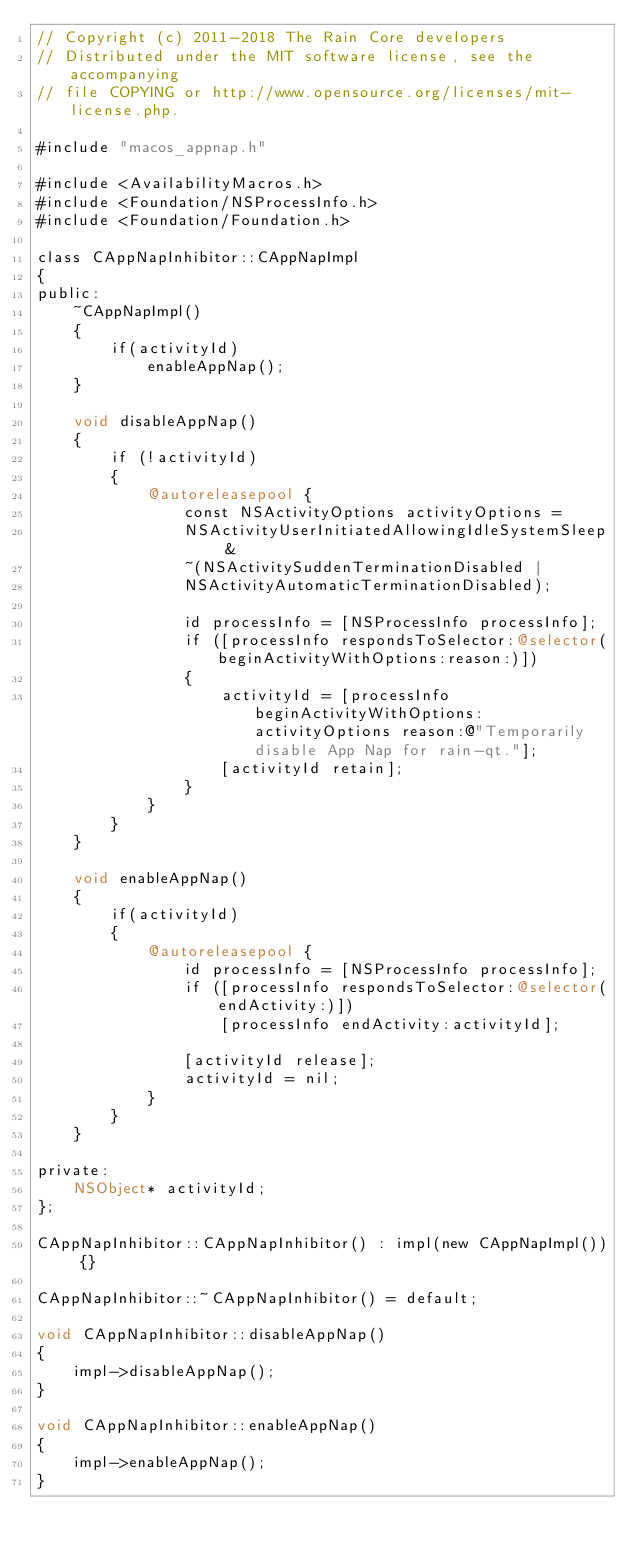Convert code to text. <code><loc_0><loc_0><loc_500><loc_500><_ObjectiveC_>// Copyright (c) 2011-2018 The Rain Core developers
// Distributed under the MIT software license, see the accompanying
// file COPYING or http://www.opensource.org/licenses/mit-license.php.

#include "macos_appnap.h"

#include <AvailabilityMacros.h>
#include <Foundation/NSProcessInfo.h>
#include <Foundation/Foundation.h>

class CAppNapInhibitor::CAppNapImpl
{
public:
    ~CAppNapImpl()
    {
        if(activityId)
            enableAppNap();
    }

    void disableAppNap()
    {
        if (!activityId)
        {
            @autoreleasepool {
                const NSActivityOptions activityOptions =
                NSActivityUserInitiatedAllowingIdleSystemSleep &
                ~(NSActivitySuddenTerminationDisabled |
                NSActivityAutomaticTerminationDisabled);

                id processInfo = [NSProcessInfo processInfo];
                if ([processInfo respondsToSelector:@selector(beginActivityWithOptions:reason:)])
                {
                    activityId = [processInfo beginActivityWithOptions: activityOptions reason:@"Temporarily disable App Nap for rain-qt."];
                    [activityId retain];
                }
            }
        }
    }

    void enableAppNap()
    {
        if(activityId)
        {
            @autoreleasepool {
                id processInfo = [NSProcessInfo processInfo];
                if ([processInfo respondsToSelector:@selector(endActivity:)])
                    [processInfo endActivity:activityId];

                [activityId release];
                activityId = nil;
            }
        }
    }

private:
    NSObject* activityId;
};

CAppNapInhibitor::CAppNapInhibitor() : impl(new CAppNapImpl()) {}

CAppNapInhibitor::~CAppNapInhibitor() = default;

void CAppNapInhibitor::disableAppNap()
{
    impl->disableAppNap();
}

void CAppNapInhibitor::enableAppNap()
{
    impl->enableAppNap();
}
</code> 